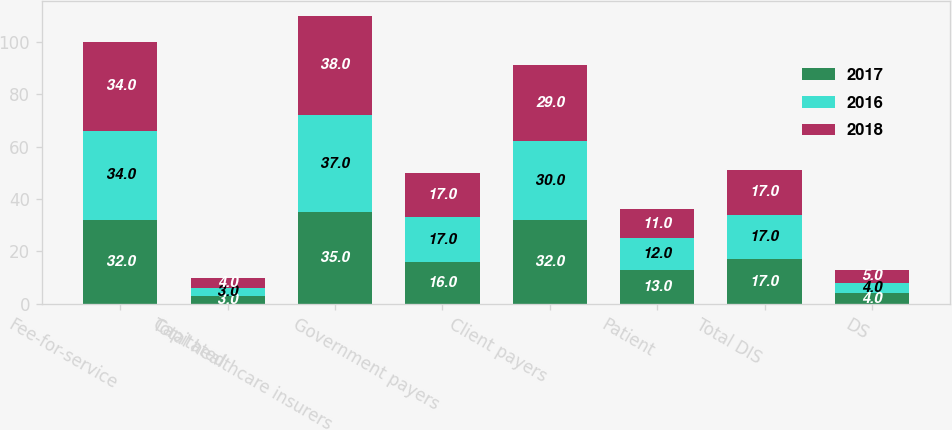<chart> <loc_0><loc_0><loc_500><loc_500><stacked_bar_chart><ecel><fcel>Fee-for-service<fcel>Capitated<fcel>Total healthcare insurers<fcel>Government payers<fcel>Client payers<fcel>Patient<fcel>Total DIS<fcel>DS<nl><fcel>2017<fcel>32<fcel>3<fcel>35<fcel>16<fcel>32<fcel>13<fcel>17<fcel>4<nl><fcel>2016<fcel>34<fcel>3<fcel>37<fcel>17<fcel>30<fcel>12<fcel>17<fcel>4<nl><fcel>2018<fcel>34<fcel>4<fcel>38<fcel>17<fcel>29<fcel>11<fcel>17<fcel>5<nl></chart> 